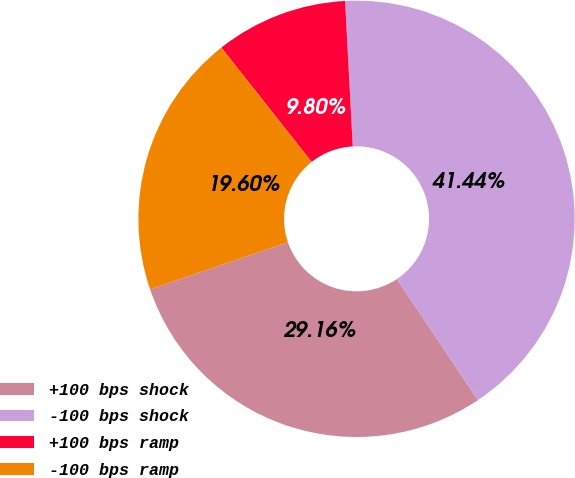Convert chart to OTSL. <chart><loc_0><loc_0><loc_500><loc_500><pie_chart><fcel>+100 bps shock<fcel>-100 bps shock<fcel>+100 bps ramp<fcel>-100 bps ramp<nl><fcel>29.16%<fcel>41.44%<fcel>9.8%<fcel>19.6%<nl></chart> 